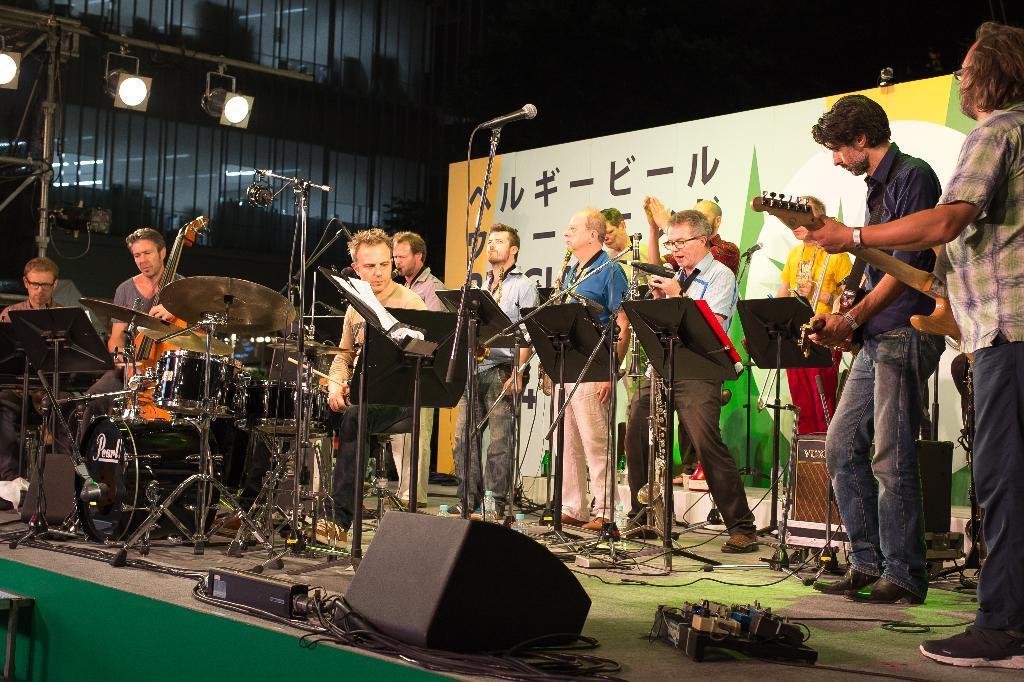Describe this image in one or two sentences. In this image we can see some group of persons standing and some are sitting on stage playing some musical instruments, there are some microphones, stands, sound boxes on stage and in the background of the image there is a sheet and some glass building. 